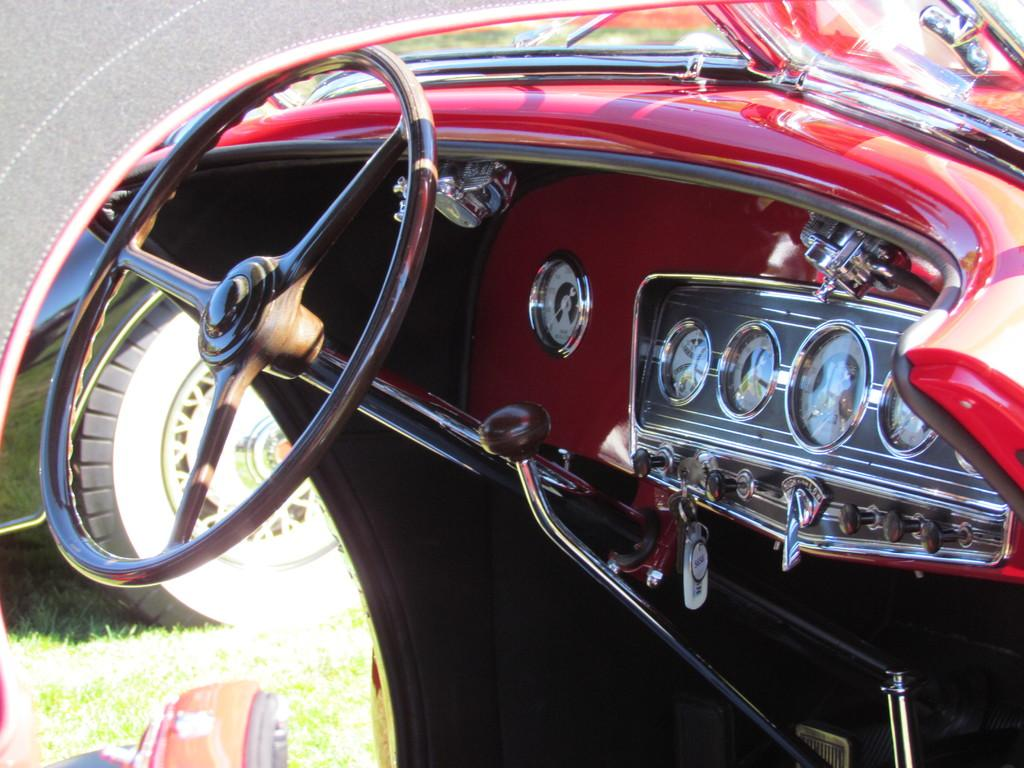What type of vehicle is shown in the image? The image shows an interior view of a car. What is the main control device in the car? There is a steering wheel in the car. How can the driver monitor their speed in the car? There is a speedometer in the car. What can be seen outside the car through the windows? The ground outside the car is covered with grass. Are there any fangs visible in the image? No, there are no fangs present in the image. Can you see a nest in the car? No, there is no nest visible in the image. 